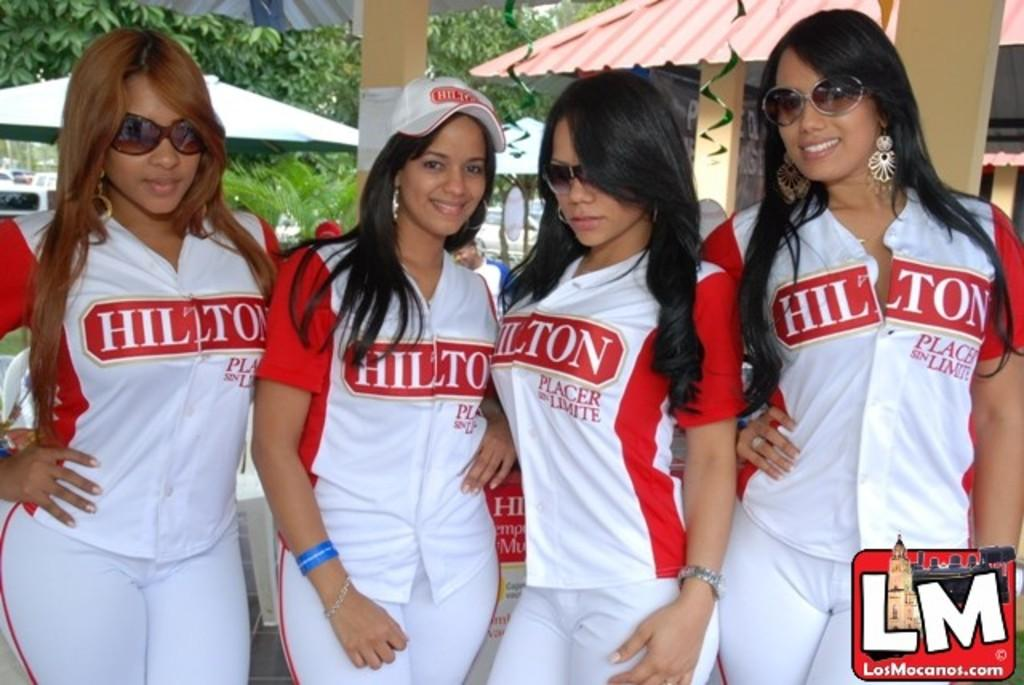<image>
Offer a succinct explanation of the picture presented. Four women posing for a photo while wearing a shirt which says HILTON. 